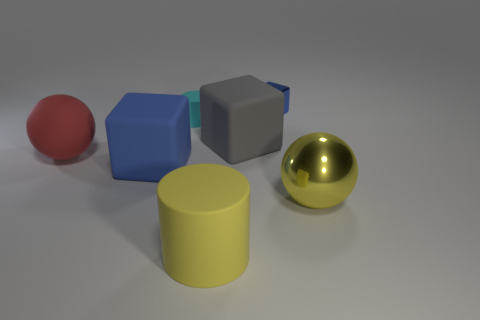Add 1 gray matte spheres. How many objects exist? 8 Subtract all cylinders. How many objects are left? 5 Add 4 matte things. How many matte things are left? 9 Add 6 tiny blue metal cubes. How many tiny blue metal cubes exist? 7 Subtract 0 red blocks. How many objects are left? 7 Subtract all blue metal cubes. Subtract all tiny cubes. How many objects are left? 5 